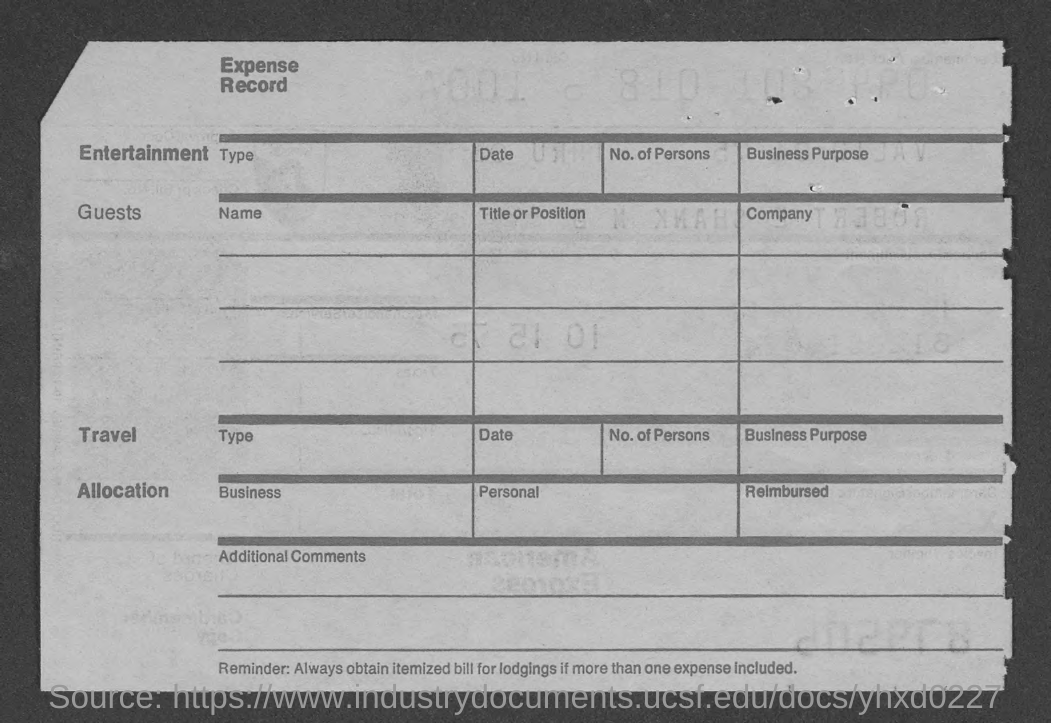What is the title of the record?
Your answer should be compact. Expense record. 